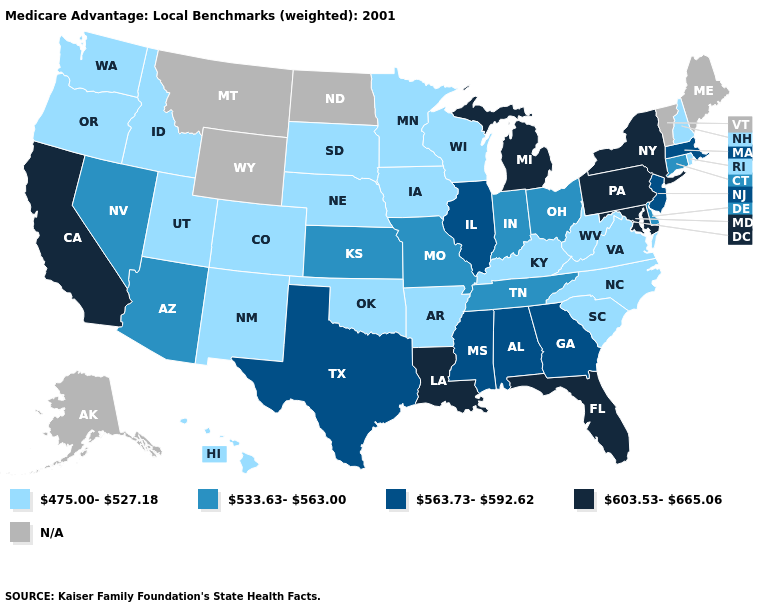Does Pennsylvania have the lowest value in the Northeast?
Give a very brief answer. No. What is the value of North Carolina?
Write a very short answer. 475.00-527.18. Does Illinois have the lowest value in the USA?
Concise answer only. No. Which states have the lowest value in the USA?
Give a very brief answer. Arkansas, Colorado, Hawaii, Iowa, Idaho, Kentucky, Minnesota, North Carolina, Nebraska, New Hampshire, New Mexico, Oklahoma, Oregon, Rhode Island, South Carolina, South Dakota, Utah, Virginia, Washington, Wisconsin, West Virginia. Name the states that have a value in the range 475.00-527.18?
Quick response, please. Arkansas, Colorado, Hawaii, Iowa, Idaho, Kentucky, Minnesota, North Carolina, Nebraska, New Hampshire, New Mexico, Oklahoma, Oregon, Rhode Island, South Carolina, South Dakota, Utah, Virginia, Washington, Wisconsin, West Virginia. Name the states that have a value in the range N/A?
Be succinct. Alaska, Maine, Montana, North Dakota, Vermont, Wyoming. What is the value of Connecticut?
Quick response, please. 533.63-563.00. Among the states that border Utah , does New Mexico have the lowest value?
Concise answer only. Yes. What is the value of Maryland?
Give a very brief answer. 603.53-665.06. Name the states that have a value in the range 563.73-592.62?
Answer briefly. Alabama, Georgia, Illinois, Massachusetts, Mississippi, New Jersey, Texas. Name the states that have a value in the range 533.63-563.00?
Keep it brief. Arizona, Connecticut, Delaware, Indiana, Kansas, Missouri, Nevada, Ohio, Tennessee. Name the states that have a value in the range N/A?
Answer briefly. Alaska, Maine, Montana, North Dakota, Vermont, Wyoming. What is the value of Iowa?
Answer briefly. 475.00-527.18. What is the lowest value in the USA?
Be succinct. 475.00-527.18. Name the states that have a value in the range 475.00-527.18?
Keep it brief. Arkansas, Colorado, Hawaii, Iowa, Idaho, Kentucky, Minnesota, North Carolina, Nebraska, New Hampshire, New Mexico, Oklahoma, Oregon, Rhode Island, South Carolina, South Dakota, Utah, Virginia, Washington, Wisconsin, West Virginia. 